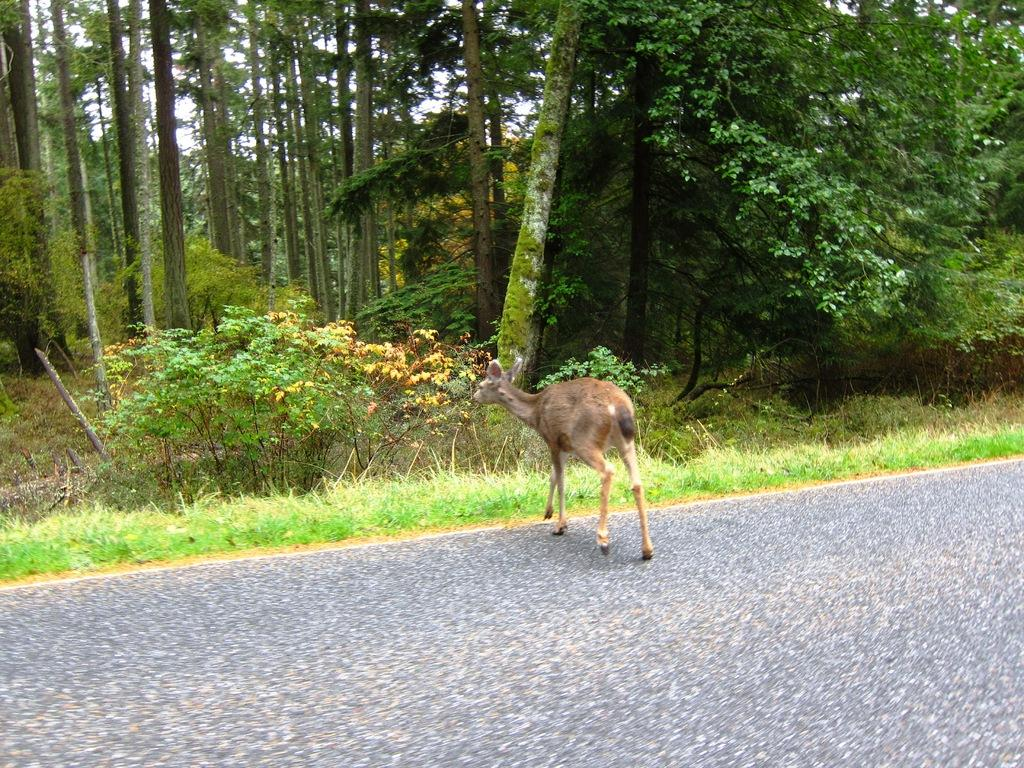What type of living creature is in the image? There is an animal in the image. What type of vegetation can be seen in the image? There is grass, plants, and trees in the image. What part of the natural environment is visible in the image? The sky is visible in the image. What type of man-made structure is present in the image? There is a road at the bottom of the image. What type of twig is the animal using to begin baking a loaf in the image? There is no twig, baking, or loaf present in the image. 